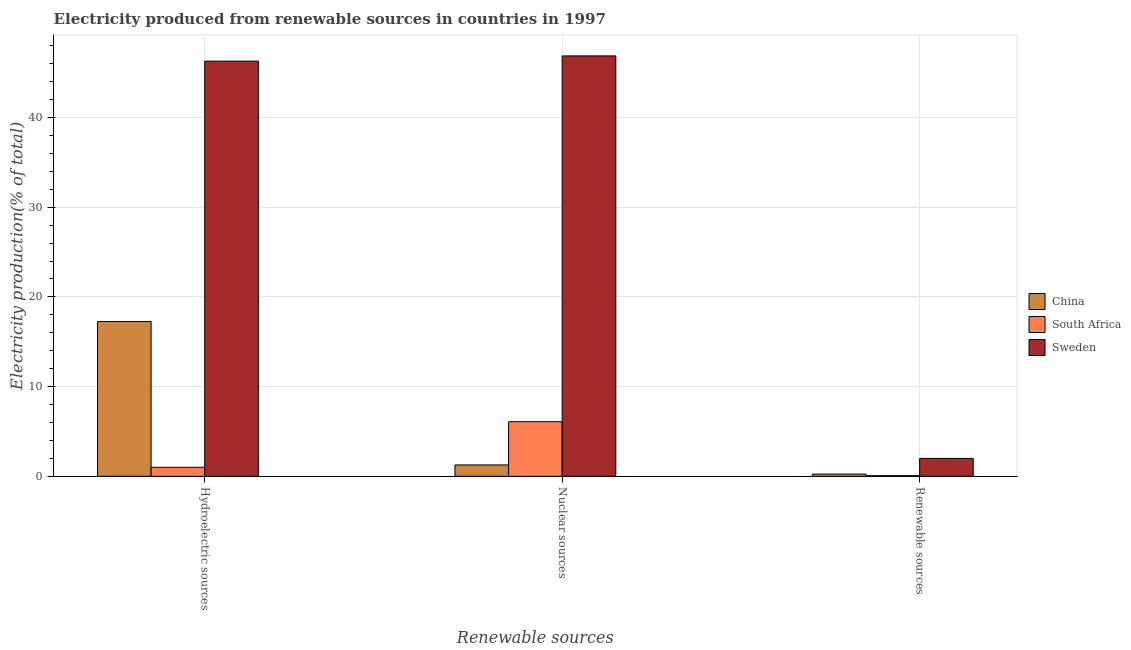How many groups of bars are there?
Keep it short and to the point. 3. Are the number of bars per tick equal to the number of legend labels?
Offer a very short reply. Yes. How many bars are there on the 1st tick from the left?
Provide a succinct answer. 3. What is the label of the 2nd group of bars from the left?
Keep it short and to the point. Nuclear sources. What is the percentage of electricity produced by renewable sources in South Africa?
Provide a succinct answer. 0.07. Across all countries, what is the maximum percentage of electricity produced by nuclear sources?
Provide a short and direct response. 46.87. Across all countries, what is the minimum percentage of electricity produced by renewable sources?
Provide a short and direct response. 0.07. In which country was the percentage of electricity produced by nuclear sources maximum?
Offer a terse response. Sweden. In which country was the percentage of electricity produced by hydroelectric sources minimum?
Your answer should be compact. South Africa. What is the total percentage of electricity produced by hydroelectric sources in the graph?
Provide a short and direct response. 64.54. What is the difference between the percentage of electricity produced by hydroelectric sources in Sweden and that in South Africa?
Provide a succinct answer. 45.28. What is the difference between the percentage of electricity produced by hydroelectric sources in Sweden and the percentage of electricity produced by renewable sources in China?
Provide a succinct answer. 46.03. What is the average percentage of electricity produced by hydroelectric sources per country?
Offer a terse response. 21.51. What is the difference between the percentage of electricity produced by hydroelectric sources and percentage of electricity produced by renewable sources in China?
Make the answer very short. 17.01. In how many countries, is the percentage of electricity produced by nuclear sources greater than 32 %?
Keep it short and to the point. 1. What is the ratio of the percentage of electricity produced by renewable sources in China to that in South Africa?
Offer a terse response. 3.54. What is the difference between the highest and the second highest percentage of electricity produced by renewable sources?
Your answer should be compact. 1.75. What is the difference between the highest and the lowest percentage of electricity produced by hydroelectric sources?
Make the answer very short. 45.28. Is the sum of the percentage of electricity produced by hydroelectric sources in China and Sweden greater than the maximum percentage of electricity produced by renewable sources across all countries?
Your answer should be very brief. Yes. What does the 3rd bar from the right in Renewable sources represents?
Keep it short and to the point. China. How many bars are there?
Your response must be concise. 9. Where does the legend appear in the graph?
Offer a very short reply. Center right. What is the title of the graph?
Keep it short and to the point. Electricity produced from renewable sources in countries in 1997. Does "Singapore" appear as one of the legend labels in the graph?
Provide a succinct answer. No. What is the label or title of the X-axis?
Give a very brief answer. Renewable sources. What is the label or title of the Y-axis?
Make the answer very short. Electricity production(% of total). What is the Electricity production(% of total) of China in Hydroelectric sources?
Your response must be concise. 17.26. What is the Electricity production(% of total) in South Africa in Hydroelectric sources?
Provide a short and direct response. 1.01. What is the Electricity production(% of total) in Sweden in Hydroelectric sources?
Your answer should be very brief. 46.28. What is the Electricity production(% of total) in China in Nuclear sources?
Make the answer very short. 1.27. What is the Electricity production(% of total) of South Africa in Nuclear sources?
Offer a terse response. 6.09. What is the Electricity production(% of total) of Sweden in Nuclear sources?
Your response must be concise. 46.87. What is the Electricity production(% of total) of China in Renewable sources?
Make the answer very short. 0.25. What is the Electricity production(% of total) of South Africa in Renewable sources?
Give a very brief answer. 0.07. What is the Electricity production(% of total) of Sweden in Renewable sources?
Offer a very short reply. 2. Across all Renewable sources, what is the maximum Electricity production(% of total) of China?
Your response must be concise. 17.26. Across all Renewable sources, what is the maximum Electricity production(% of total) of South Africa?
Provide a succinct answer. 6.09. Across all Renewable sources, what is the maximum Electricity production(% of total) of Sweden?
Offer a terse response. 46.87. Across all Renewable sources, what is the minimum Electricity production(% of total) of China?
Provide a succinct answer. 0.25. Across all Renewable sources, what is the minimum Electricity production(% of total) of South Africa?
Offer a very short reply. 0.07. Across all Renewable sources, what is the minimum Electricity production(% of total) in Sweden?
Ensure brevity in your answer.  2. What is the total Electricity production(% of total) in China in the graph?
Provide a succinct answer. 18.77. What is the total Electricity production(% of total) in South Africa in the graph?
Provide a succinct answer. 7.16. What is the total Electricity production(% of total) in Sweden in the graph?
Offer a terse response. 95.14. What is the difference between the Electricity production(% of total) in China in Hydroelectric sources and that in Nuclear sources?
Your answer should be compact. 15.99. What is the difference between the Electricity production(% of total) in South Africa in Hydroelectric sources and that in Nuclear sources?
Give a very brief answer. -5.08. What is the difference between the Electricity production(% of total) of Sweden in Hydroelectric sources and that in Nuclear sources?
Ensure brevity in your answer.  -0.58. What is the difference between the Electricity production(% of total) of China in Hydroelectric sources and that in Renewable sources?
Your response must be concise. 17.01. What is the difference between the Electricity production(% of total) in South Africa in Hydroelectric sources and that in Renewable sources?
Keep it short and to the point. 0.94. What is the difference between the Electricity production(% of total) in Sweden in Hydroelectric sources and that in Renewable sources?
Offer a very short reply. 44.29. What is the difference between the Electricity production(% of total) of China in Nuclear sources and that in Renewable sources?
Keep it short and to the point. 1.02. What is the difference between the Electricity production(% of total) in South Africa in Nuclear sources and that in Renewable sources?
Offer a terse response. 6.02. What is the difference between the Electricity production(% of total) of Sweden in Nuclear sources and that in Renewable sources?
Your answer should be very brief. 44.87. What is the difference between the Electricity production(% of total) in China in Hydroelectric sources and the Electricity production(% of total) in South Africa in Nuclear sources?
Your response must be concise. 11.17. What is the difference between the Electricity production(% of total) of China in Hydroelectric sources and the Electricity production(% of total) of Sweden in Nuclear sources?
Give a very brief answer. -29.61. What is the difference between the Electricity production(% of total) in South Africa in Hydroelectric sources and the Electricity production(% of total) in Sweden in Nuclear sources?
Give a very brief answer. -45.86. What is the difference between the Electricity production(% of total) in China in Hydroelectric sources and the Electricity production(% of total) in South Africa in Renewable sources?
Offer a terse response. 17.19. What is the difference between the Electricity production(% of total) of China in Hydroelectric sources and the Electricity production(% of total) of Sweden in Renewable sources?
Give a very brief answer. 15.26. What is the difference between the Electricity production(% of total) in South Africa in Hydroelectric sources and the Electricity production(% of total) in Sweden in Renewable sources?
Provide a succinct answer. -0.99. What is the difference between the Electricity production(% of total) of China in Nuclear sources and the Electricity production(% of total) of South Africa in Renewable sources?
Provide a succinct answer. 1.2. What is the difference between the Electricity production(% of total) in China in Nuclear sources and the Electricity production(% of total) in Sweden in Renewable sources?
Your answer should be very brief. -0.73. What is the difference between the Electricity production(% of total) of South Africa in Nuclear sources and the Electricity production(% of total) of Sweden in Renewable sources?
Your answer should be compact. 4.09. What is the average Electricity production(% of total) of China per Renewable sources?
Provide a succinct answer. 6.26. What is the average Electricity production(% of total) of South Africa per Renewable sources?
Provide a short and direct response. 2.39. What is the average Electricity production(% of total) in Sweden per Renewable sources?
Ensure brevity in your answer.  31.71. What is the difference between the Electricity production(% of total) of China and Electricity production(% of total) of South Africa in Hydroelectric sources?
Make the answer very short. 16.25. What is the difference between the Electricity production(% of total) in China and Electricity production(% of total) in Sweden in Hydroelectric sources?
Provide a short and direct response. -29.03. What is the difference between the Electricity production(% of total) of South Africa and Electricity production(% of total) of Sweden in Hydroelectric sources?
Ensure brevity in your answer.  -45.28. What is the difference between the Electricity production(% of total) of China and Electricity production(% of total) of South Africa in Nuclear sources?
Your answer should be very brief. -4.82. What is the difference between the Electricity production(% of total) of China and Electricity production(% of total) of Sweden in Nuclear sources?
Offer a very short reply. -45.6. What is the difference between the Electricity production(% of total) in South Africa and Electricity production(% of total) in Sweden in Nuclear sources?
Make the answer very short. -40.78. What is the difference between the Electricity production(% of total) of China and Electricity production(% of total) of South Africa in Renewable sources?
Your answer should be very brief. 0.18. What is the difference between the Electricity production(% of total) in China and Electricity production(% of total) in Sweden in Renewable sources?
Offer a terse response. -1.75. What is the difference between the Electricity production(% of total) in South Africa and Electricity production(% of total) in Sweden in Renewable sources?
Keep it short and to the point. -1.93. What is the ratio of the Electricity production(% of total) of China in Hydroelectric sources to that in Nuclear sources?
Your response must be concise. 13.59. What is the ratio of the Electricity production(% of total) of South Africa in Hydroelectric sources to that in Nuclear sources?
Ensure brevity in your answer.  0.17. What is the ratio of the Electricity production(% of total) in Sweden in Hydroelectric sources to that in Nuclear sources?
Your answer should be very brief. 0.99. What is the ratio of the Electricity production(% of total) in China in Hydroelectric sources to that in Renewable sources?
Your response must be concise. 69.42. What is the ratio of the Electricity production(% of total) of South Africa in Hydroelectric sources to that in Renewable sources?
Offer a terse response. 14.33. What is the ratio of the Electricity production(% of total) in Sweden in Hydroelectric sources to that in Renewable sources?
Your answer should be compact. 23.2. What is the ratio of the Electricity production(% of total) in China in Nuclear sources to that in Renewable sources?
Give a very brief answer. 5.11. What is the ratio of the Electricity production(% of total) of South Africa in Nuclear sources to that in Renewable sources?
Ensure brevity in your answer.  86.62. What is the ratio of the Electricity production(% of total) in Sweden in Nuclear sources to that in Renewable sources?
Make the answer very short. 23.49. What is the difference between the highest and the second highest Electricity production(% of total) in China?
Ensure brevity in your answer.  15.99. What is the difference between the highest and the second highest Electricity production(% of total) of South Africa?
Offer a terse response. 5.08. What is the difference between the highest and the second highest Electricity production(% of total) in Sweden?
Your answer should be very brief. 0.58. What is the difference between the highest and the lowest Electricity production(% of total) in China?
Give a very brief answer. 17.01. What is the difference between the highest and the lowest Electricity production(% of total) in South Africa?
Offer a terse response. 6.02. What is the difference between the highest and the lowest Electricity production(% of total) in Sweden?
Ensure brevity in your answer.  44.87. 